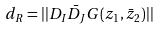<formula> <loc_0><loc_0><loc_500><loc_500>d _ { R } = | | D _ { I } \bar { D } _ { J } G ( z _ { 1 } , \bar { z } _ { 2 } ) | |</formula> 